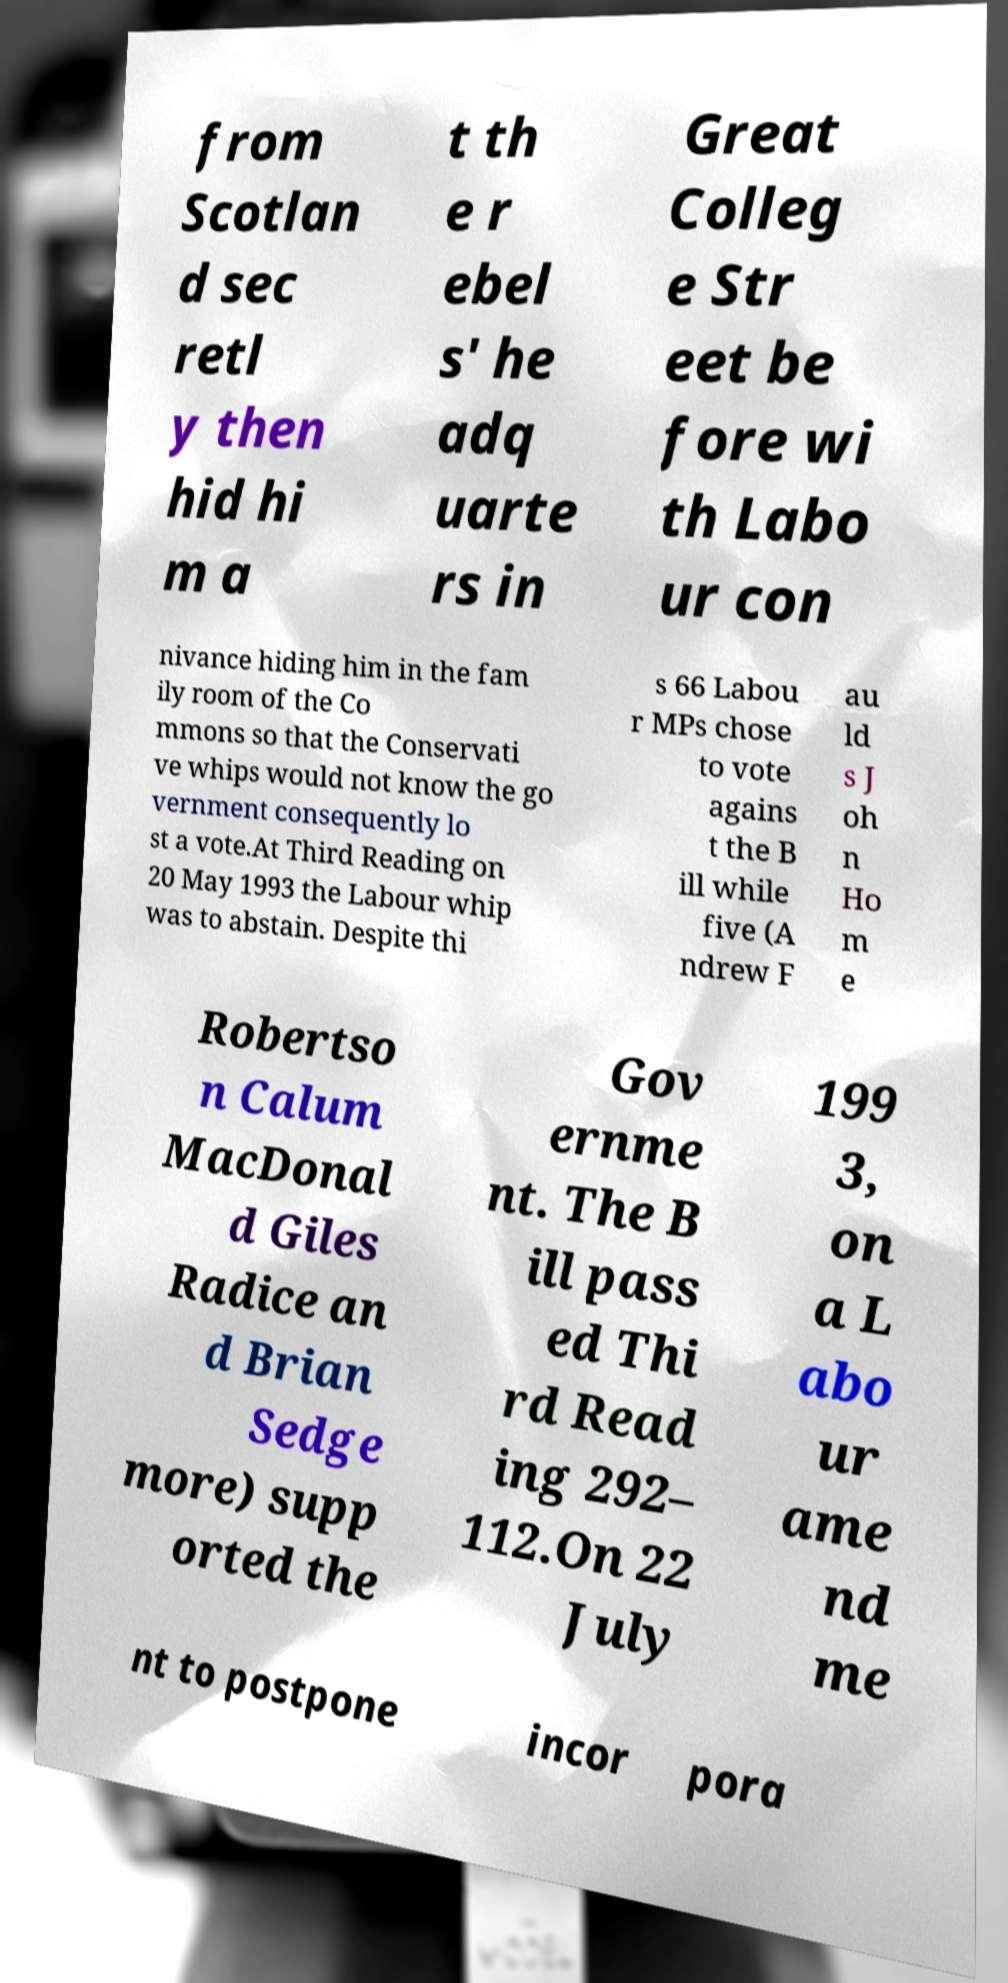Can you read and provide the text displayed in the image?This photo seems to have some interesting text. Can you extract and type it out for me? from Scotlan d sec retl y then hid hi m a t th e r ebel s' he adq uarte rs in Great Colleg e Str eet be fore wi th Labo ur con nivance hiding him in the fam ily room of the Co mmons so that the Conservati ve whips would not know the go vernment consequently lo st a vote.At Third Reading on 20 May 1993 the Labour whip was to abstain. Despite thi s 66 Labou r MPs chose to vote agains t the B ill while five (A ndrew F au ld s J oh n Ho m e Robertso n Calum MacDonal d Giles Radice an d Brian Sedge more) supp orted the Gov ernme nt. The B ill pass ed Thi rd Read ing 292– 112.On 22 July 199 3, on a L abo ur ame nd me nt to postpone incor pora 